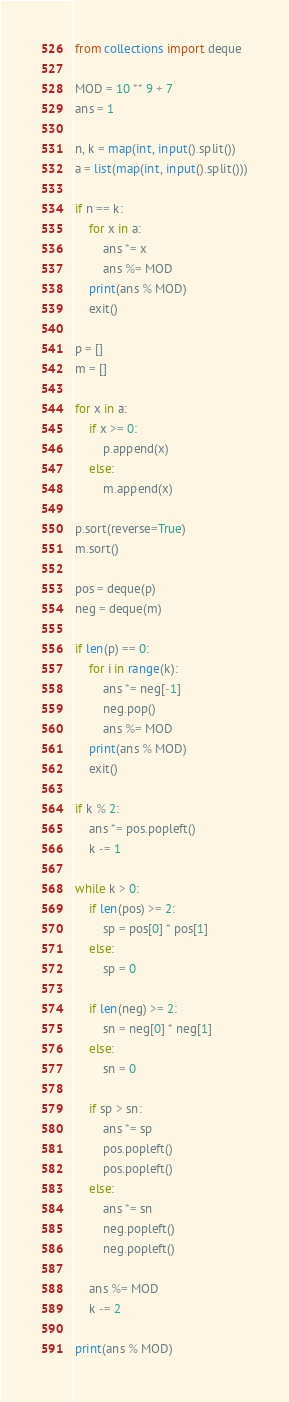<code> <loc_0><loc_0><loc_500><loc_500><_Python_>from collections import deque

MOD = 10 ** 9 + 7
ans = 1

n, k = map(int, input().split())
a = list(map(int, input().split()))

if n == k:
    for x in a:
        ans *= x
        ans %= MOD
    print(ans % MOD)
    exit()

p = []
m = []

for x in a:
    if x >= 0:
        p.append(x)
    else:
        m.append(x)

p.sort(reverse=True)
m.sort()

pos = deque(p)
neg = deque(m)

if len(p) == 0:
    for i in range(k):
        ans *= neg[-1]
        neg.pop()
        ans %= MOD
    print(ans % MOD)
    exit()

if k % 2:
    ans *= pos.popleft()
    k -= 1

while k > 0:
    if len(pos) >= 2:
        sp = pos[0] * pos[1]
    else:
        sp = 0
    
    if len(neg) >= 2:
        sn = neg[0] * neg[1]
    else:
        sn = 0
    
    if sp > sn:
        ans *= sp
        pos.popleft()
        pos.popleft()
    else:
        ans *= sn
        neg.popleft()
        neg.popleft()
    
    ans %= MOD
    k -= 2

print(ans % MOD)
</code> 